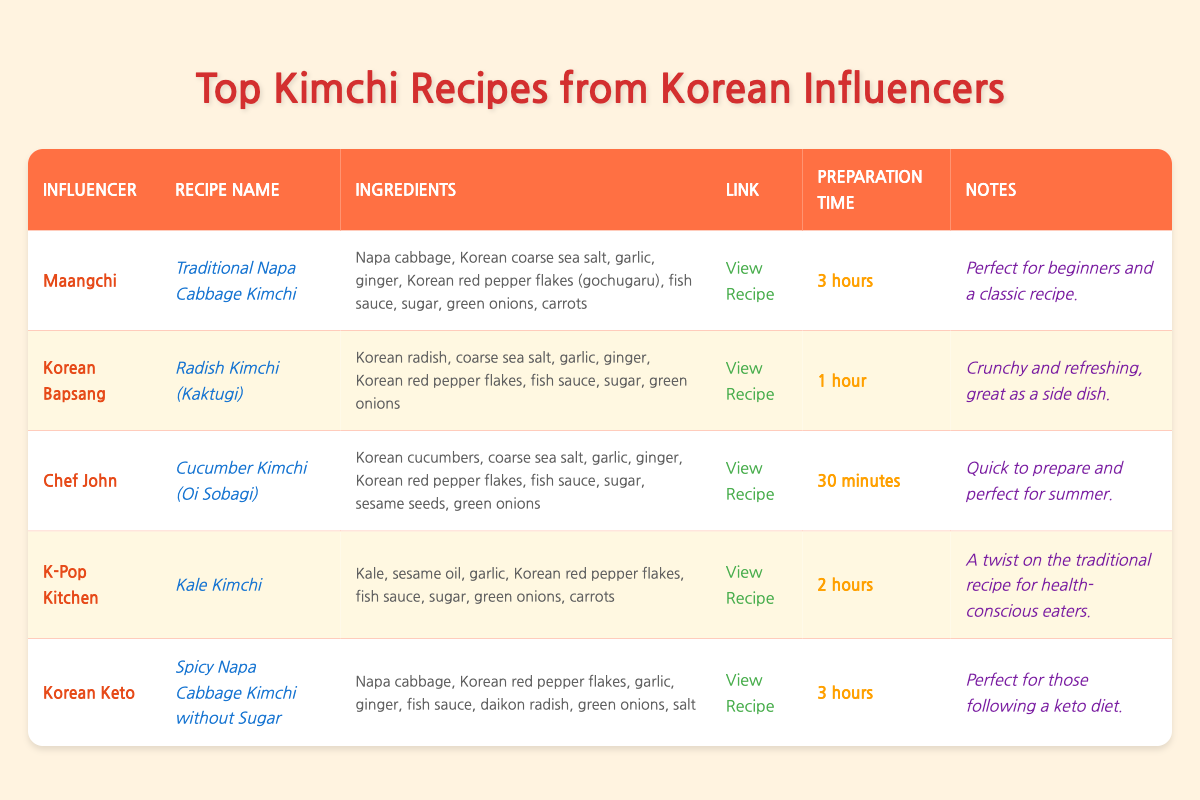What is the preparation time for the "Cucumber Kimchi (Oi Sobagi)" recipe? The preparation time is listed directly in the table under the "Preparation Time" column for the "Cucumber Kimchi (Oi Sobagi)" recipe. It shows "30 minutes."
Answer: 30 minutes Which influencer has a recipe that takes the longest to prepare? I will check the "Preparation Time" column for each recipe to find the longest entry. "Traditional Napa Cabbage Kimchi" and "Spicy Napa Cabbage Kimchi without Sugar" each have a preparation time of "3 hours," which is the longest.
Answer: Maangchi and Korean Keto Is "Kale Kimchi" suitable for health-conscious eaters? The notes for "Kale Kimchi" mention it is "A twist on the traditional recipe for health-conscious eaters," indicating that it is indeed suitable for them.
Answer: Yes What is the total number of recipes listed in the table? I will count each row under the "tbody" section, where all recipes are listed. There are a total of 5 recipes shown in the table.
Answer: 5 Which recipe requires the least amount of preparation time and what is that time? I will compare the preparation times: "1 hour" for Radish Kimchi, "30 minutes" for Cucumber Kimchi, and others. The shortest preparation time is "30 minutes."
Answer: Cucumber Kimchi (Oi Sobagi), 30 minutes How many recipes contain fish sauce as an ingredient? By reviewing the ingredients list for each recipe, I can identify those that include "fish sauce." It appears in 4 out of the 5 recipes.
Answer: 4 Which recipe is specifically designed for someone following a keto diet? By checking the recipe notes, "Spicy Napa Cabbage Kimchi without Sugar" is explicitly noted as being suitable for a keto diet.
Answer: Spicy Napa Cabbage Kimchi without Sugar What are the ingredients needed for the "Radish Kimchi (Kaktugi)" recipe? The ingredients are listed in the corresponding row for "Radish Kimchi (Kaktugi)," which includes Korean radish, coarse sea salt, garlic, ginger, Korean red pepper flakes, fish sauce, sugar, and green onions.
Answer: Korean radish, coarse sea salt, garlic, ginger, Korean red pepper flakes, fish sauce, sugar, green onions What is the difference in preparation time between "Kale Kimchi" and "Cucumber Kimchi (Oi Sobagi)"? "Kale Kimchi" takes 2 hours and "Cucumber Kimchi" takes 30 minutes. Converting 2 hours to minutes gives us 120 minutes; thus, the difference is: 120 - 30 = 90 minutes.
Answer: 90 minutes Which influencer is associated with the recipe that has the note "Perfect for beginners and a classic recipe"? This note is found in the row for "Traditional Napa Cabbage Kimchi," associated with influencer Maangchi.
Answer: Maangchi 